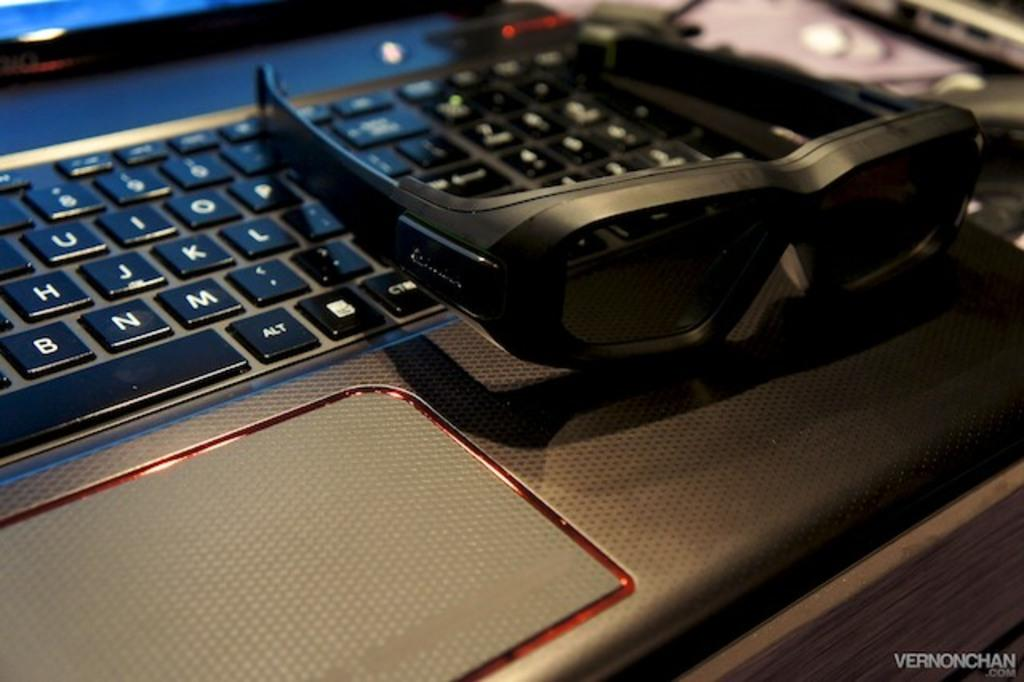<image>
Give a short and clear explanation of the subsequent image. A pair of black glasses sitting on a laptop where an alt and ctrl key can be seen. 